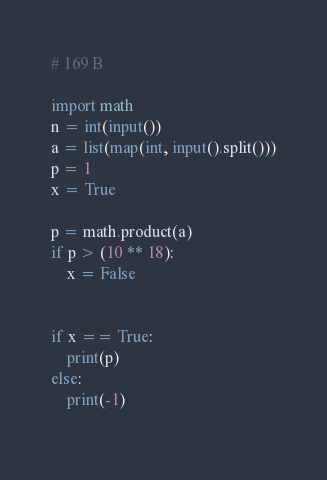<code> <loc_0><loc_0><loc_500><loc_500><_Python_># 169 B

import math
n = int(input())
a = list(map(int, input().split()))
p = 1
x = True

p = math.product(a)
if p > (10 ** 18):
    x = False


if x == True:
    print(p)
else:
    print(-1)
        </code> 